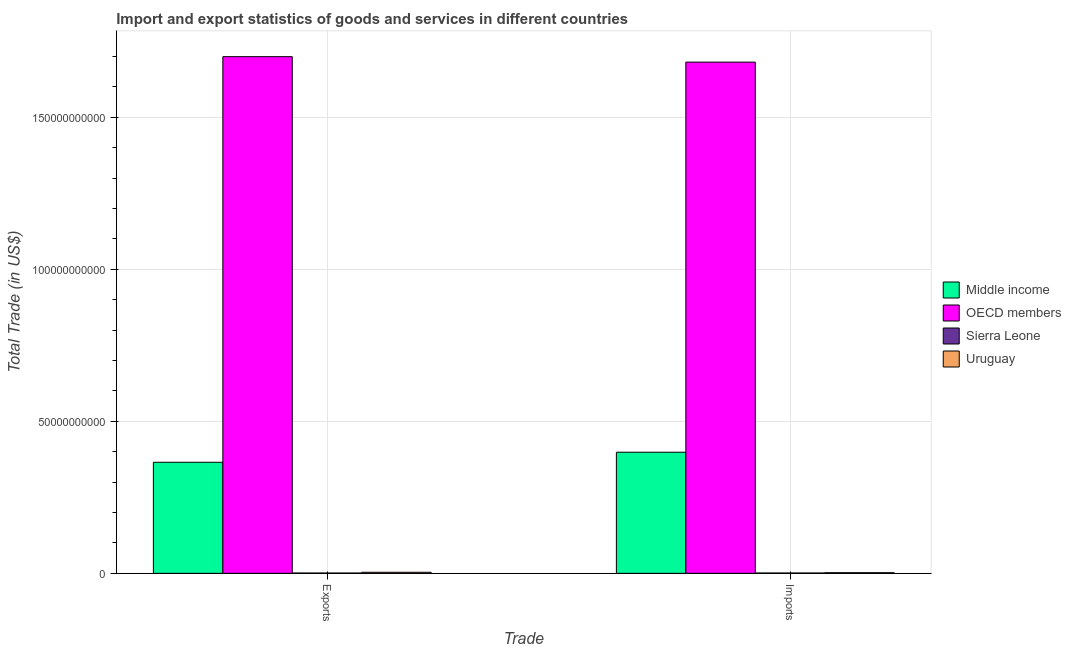How many different coloured bars are there?
Your answer should be very brief. 4. How many groups of bars are there?
Make the answer very short. 2. Are the number of bars per tick equal to the number of legend labels?
Make the answer very short. Yes. Are the number of bars on each tick of the X-axis equal?
Offer a terse response. Yes. What is the label of the 2nd group of bars from the left?
Keep it short and to the point. Imports. What is the export of goods and services in OECD members?
Provide a succinct answer. 1.70e+11. Across all countries, what is the maximum export of goods and services?
Make the answer very short. 1.70e+11. Across all countries, what is the minimum imports of goods and services?
Offer a terse response. 1.12e+08. In which country was the imports of goods and services maximum?
Your response must be concise. OECD members. In which country was the imports of goods and services minimum?
Your answer should be compact. Sierra Leone. What is the total export of goods and services in the graph?
Keep it short and to the point. 2.07e+11. What is the difference between the imports of goods and services in Uruguay and that in OECD members?
Your response must be concise. -1.68e+11. What is the difference between the imports of goods and services in Sierra Leone and the export of goods and services in OECD members?
Make the answer very short. -1.70e+11. What is the average export of goods and services per country?
Ensure brevity in your answer.  5.17e+1. What is the difference between the imports of goods and services and export of goods and services in Middle income?
Offer a very short reply. 3.31e+09. What is the ratio of the export of goods and services in Sierra Leone to that in OECD members?
Offer a very short reply. 0. In how many countries, is the export of goods and services greater than the average export of goods and services taken over all countries?
Your answer should be very brief. 1. What does the 2nd bar from the left in Exports represents?
Ensure brevity in your answer.  OECD members. Does the graph contain any zero values?
Offer a very short reply. No. Does the graph contain grids?
Give a very brief answer. Yes. Where does the legend appear in the graph?
Give a very brief answer. Center right. How many legend labels are there?
Make the answer very short. 4. What is the title of the graph?
Offer a terse response. Import and export statistics of goods and services in different countries. Does "Kazakhstan" appear as one of the legend labels in the graph?
Provide a short and direct response. No. What is the label or title of the X-axis?
Give a very brief answer. Trade. What is the label or title of the Y-axis?
Ensure brevity in your answer.  Total Trade (in US$). What is the Total Trade (in US$) in Middle income in Exports?
Your answer should be compact. 3.65e+1. What is the Total Trade (in US$) of OECD members in Exports?
Keep it short and to the point. 1.70e+11. What is the Total Trade (in US$) of Sierra Leone in Exports?
Provide a short and direct response. 1.04e+08. What is the Total Trade (in US$) in Uruguay in Exports?
Your answer should be compact. 3.48e+08. What is the Total Trade (in US$) of Middle income in Imports?
Keep it short and to the point. 3.98e+1. What is the Total Trade (in US$) of OECD members in Imports?
Offer a terse response. 1.68e+11. What is the Total Trade (in US$) of Sierra Leone in Imports?
Your response must be concise. 1.12e+08. What is the Total Trade (in US$) of Uruguay in Imports?
Your response must be concise. 2.17e+08. Across all Trade, what is the maximum Total Trade (in US$) of Middle income?
Keep it short and to the point. 3.98e+1. Across all Trade, what is the maximum Total Trade (in US$) of OECD members?
Provide a short and direct response. 1.70e+11. Across all Trade, what is the maximum Total Trade (in US$) in Sierra Leone?
Offer a terse response. 1.12e+08. Across all Trade, what is the maximum Total Trade (in US$) of Uruguay?
Give a very brief answer. 3.48e+08. Across all Trade, what is the minimum Total Trade (in US$) of Middle income?
Offer a terse response. 3.65e+1. Across all Trade, what is the minimum Total Trade (in US$) of OECD members?
Provide a succinct answer. 1.68e+11. Across all Trade, what is the minimum Total Trade (in US$) in Sierra Leone?
Offer a very short reply. 1.04e+08. Across all Trade, what is the minimum Total Trade (in US$) in Uruguay?
Provide a short and direct response. 2.17e+08. What is the total Total Trade (in US$) of Middle income in the graph?
Ensure brevity in your answer.  7.64e+1. What is the total Total Trade (in US$) in OECD members in the graph?
Your answer should be very brief. 3.38e+11. What is the total Total Trade (in US$) in Sierra Leone in the graph?
Make the answer very short. 2.16e+08. What is the total Total Trade (in US$) of Uruguay in the graph?
Ensure brevity in your answer.  5.65e+08. What is the difference between the Total Trade (in US$) in Middle income in Exports and that in Imports?
Give a very brief answer. -3.31e+09. What is the difference between the Total Trade (in US$) of OECD members in Exports and that in Imports?
Ensure brevity in your answer.  1.80e+09. What is the difference between the Total Trade (in US$) in Sierra Leone in Exports and that in Imports?
Keep it short and to the point. -8.68e+06. What is the difference between the Total Trade (in US$) of Uruguay in Exports and that in Imports?
Offer a terse response. 1.31e+08. What is the difference between the Total Trade (in US$) of Middle income in Exports and the Total Trade (in US$) of OECD members in Imports?
Your answer should be compact. -1.32e+11. What is the difference between the Total Trade (in US$) in Middle income in Exports and the Total Trade (in US$) in Sierra Leone in Imports?
Your answer should be very brief. 3.64e+1. What is the difference between the Total Trade (in US$) of Middle income in Exports and the Total Trade (in US$) of Uruguay in Imports?
Make the answer very short. 3.63e+1. What is the difference between the Total Trade (in US$) in OECD members in Exports and the Total Trade (in US$) in Sierra Leone in Imports?
Make the answer very short. 1.70e+11. What is the difference between the Total Trade (in US$) of OECD members in Exports and the Total Trade (in US$) of Uruguay in Imports?
Your answer should be compact. 1.70e+11. What is the difference between the Total Trade (in US$) of Sierra Leone in Exports and the Total Trade (in US$) of Uruguay in Imports?
Your answer should be very brief. -1.13e+08. What is the average Total Trade (in US$) of Middle income per Trade?
Provide a short and direct response. 3.82e+1. What is the average Total Trade (in US$) of OECD members per Trade?
Your answer should be very brief. 1.69e+11. What is the average Total Trade (in US$) in Sierra Leone per Trade?
Make the answer very short. 1.08e+08. What is the average Total Trade (in US$) in Uruguay per Trade?
Keep it short and to the point. 2.82e+08. What is the difference between the Total Trade (in US$) of Middle income and Total Trade (in US$) of OECD members in Exports?
Your response must be concise. -1.33e+11. What is the difference between the Total Trade (in US$) in Middle income and Total Trade (in US$) in Sierra Leone in Exports?
Give a very brief answer. 3.64e+1. What is the difference between the Total Trade (in US$) in Middle income and Total Trade (in US$) in Uruguay in Exports?
Provide a succinct answer. 3.62e+1. What is the difference between the Total Trade (in US$) in OECD members and Total Trade (in US$) in Sierra Leone in Exports?
Ensure brevity in your answer.  1.70e+11. What is the difference between the Total Trade (in US$) in OECD members and Total Trade (in US$) in Uruguay in Exports?
Offer a terse response. 1.70e+11. What is the difference between the Total Trade (in US$) in Sierra Leone and Total Trade (in US$) in Uruguay in Exports?
Make the answer very short. -2.44e+08. What is the difference between the Total Trade (in US$) in Middle income and Total Trade (in US$) in OECD members in Imports?
Give a very brief answer. -1.28e+11. What is the difference between the Total Trade (in US$) in Middle income and Total Trade (in US$) in Sierra Leone in Imports?
Ensure brevity in your answer.  3.97e+1. What is the difference between the Total Trade (in US$) in Middle income and Total Trade (in US$) in Uruguay in Imports?
Your response must be concise. 3.96e+1. What is the difference between the Total Trade (in US$) of OECD members and Total Trade (in US$) of Sierra Leone in Imports?
Offer a very short reply. 1.68e+11. What is the difference between the Total Trade (in US$) in OECD members and Total Trade (in US$) in Uruguay in Imports?
Offer a terse response. 1.68e+11. What is the difference between the Total Trade (in US$) in Sierra Leone and Total Trade (in US$) in Uruguay in Imports?
Your answer should be very brief. -1.05e+08. What is the ratio of the Total Trade (in US$) of Middle income in Exports to that in Imports?
Ensure brevity in your answer.  0.92. What is the ratio of the Total Trade (in US$) of OECD members in Exports to that in Imports?
Keep it short and to the point. 1.01. What is the ratio of the Total Trade (in US$) in Sierra Leone in Exports to that in Imports?
Keep it short and to the point. 0.92. What is the ratio of the Total Trade (in US$) in Uruguay in Exports to that in Imports?
Provide a short and direct response. 1.6. What is the difference between the highest and the second highest Total Trade (in US$) in Middle income?
Provide a short and direct response. 3.31e+09. What is the difference between the highest and the second highest Total Trade (in US$) in OECD members?
Provide a succinct answer. 1.80e+09. What is the difference between the highest and the second highest Total Trade (in US$) in Sierra Leone?
Make the answer very short. 8.68e+06. What is the difference between the highest and the second highest Total Trade (in US$) of Uruguay?
Offer a terse response. 1.31e+08. What is the difference between the highest and the lowest Total Trade (in US$) of Middle income?
Keep it short and to the point. 3.31e+09. What is the difference between the highest and the lowest Total Trade (in US$) of OECD members?
Provide a short and direct response. 1.80e+09. What is the difference between the highest and the lowest Total Trade (in US$) in Sierra Leone?
Offer a terse response. 8.68e+06. What is the difference between the highest and the lowest Total Trade (in US$) in Uruguay?
Your answer should be very brief. 1.31e+08. 